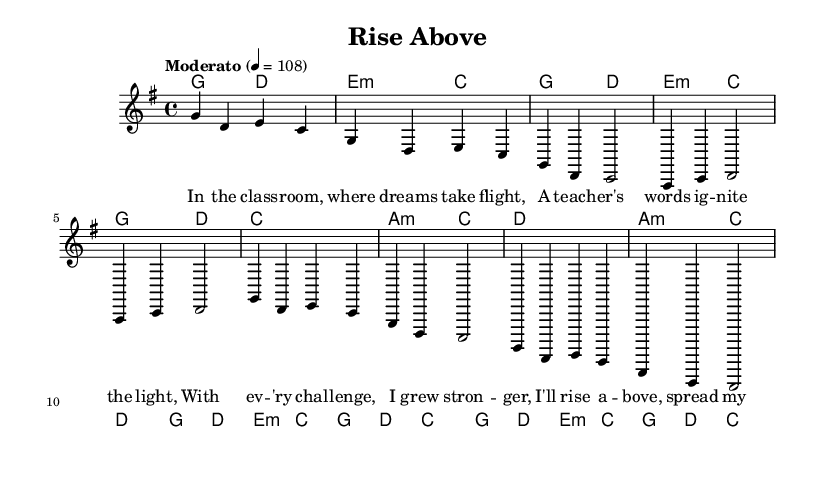What is the key signature of this music? The key signature is G major, which has one sharp (F#). This can be determined by looking at the beginning of the music sheet where the key signature is indicated.
Answer: G major What is the time signature of this music? The time signature is 4/4, as denoted at the beginning of the score. This means there are four beats in each measure and the quarter note gets one beat.
Answer: 4/4 What is the tempo marking for this piece? The tempo marking is "Moderato," which indicates a moderate speed for the music. The tempo is further specified as 4 = 108, meaning there are 108 quarter note beats per minute.
Answer: Moderato How many measures are in the chorus section? There are four measures in the chorus section. You can count the measures by looking at the chorus part of the music and identifying the measure lines.
Answer: Four What is the primary theme of the lyrics? The primary theme of the lyrics is personal growth and overcoming challenges, highlighted by phrases about rising above and spreading wings. This is inferred from the content of the verses, pre-chorus, and chorus lyrics.
Answer: Personal growth What is the first chord in the piece? The first chord in the piece is G major. This is found in the harmonies section at the start, which indicates the chords played along with the melody.
Answer: G major How does the pre-chorus differ from the verse in terms of chord progression? The pre-chorus uses a chord progression that alternates between A minor and C major, while the verse predominantly uses G major and D major. This requires comparing the chords indicated in both sections to identify the differences in progression styles.
Answer: Different chord progression 